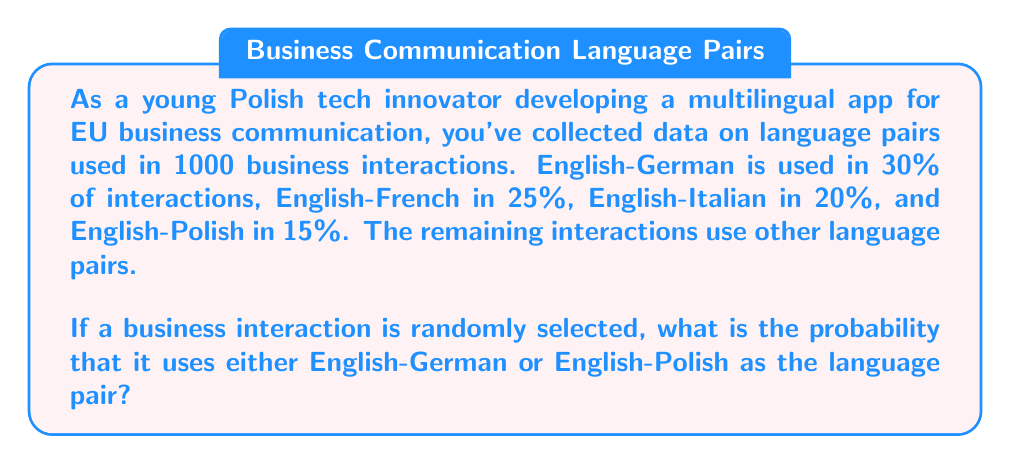What is the answer to this math problem? To solve this problem, we need to follow these steps:

1. Identify the probabilities of the events we're interested in:
   - P(English-German) = 30% = 0.30
   - P(English-Polish) = 15% = 0.15

2. Since we want the probability of either English-German OR English-Polish being used, we need to add these probabilities together:

   $$P(\text{English-German or English-Polish}) = P(\text{English-German}) + P(\text{English-Polish})$$

3. Substitute the values:

   $$P(\text{English-German or English-Polish}) = 0.30 + 0.15$$

4. Calculate the result:

   $$P(\text{English-German or English-Polish}) = 0.45$$

5. Convert to a percentage:

   $$0.45 \times 100\% = 45\%$$

Therefore, the probability that a randomly selected business interaction uses either English-German or English-Polish as the language pair is 45% or 0.45.
Answer: 45% or 0.45 